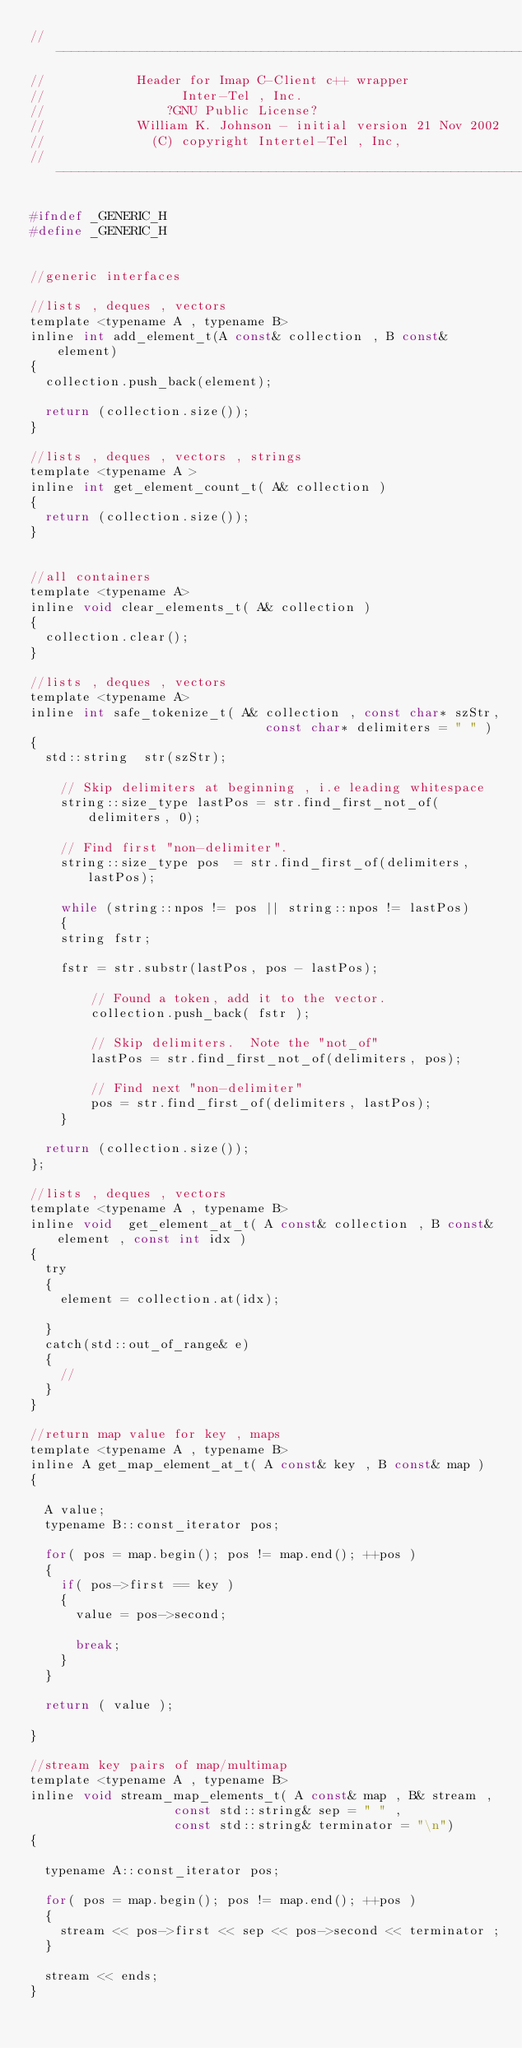Convert code to text. <code><loc_0><loc_0><loc_500><loc_500><_C_>//--------------------------------------------------------------------------------
//						Header for Imap C-Client c++ wrapper			  
//								  Inter-Tel , Inc.								  
//								?GNU Public License?							  
//						William K. Johnson - initial version 21 Nov 2002
//							(C) copyright Intertel-Tel , Inc,
//--------------------------------------------------------------------------------

#ifndef _GENERIC_H
#define _GENERIC_H


//generic interfaces

//lists , deques , vectors 
template <typename A , typename B>
inline int add_element_t(A const& collection , B const& element)
{
	collection.push_back(element);	
		
	return (collection.size());		
}

//lists , deques , vectors , strings
template <typename A >
inline int get_element_count_t( A& collection ) 
{
	return (collection.size());
}


//all containers
template <typename A>
inline void clear_elements_t( A& collection ) 
{
	collection.clear();
}

//lists , deques , vectors
template <typename A>
inline int safe_tokenize_t( A& collection , const char* szStr,
						                   const char* delimiters = " " )
{
	std::string  str(szStr);

    // Skip delimiters at beginning , i.e leading whitespace
    string::size_type lastPos = str.find_first_not_of(delimiters, 0);

    // Find first "non-delimiter".
    string::size_type pos  = str.find_first_of(delimiters, lastPos);

    while (string::npos != pos || string::npos != lastPos)
    {
		string fstr;

		fstr = str.substr(lastPos, pos - lastPos);

        // Found a token, add it to the vector.
        collection.push_back( fstr );

        // Skip delimiters.  Note the "not_of"
        lastPos = str.find_first_not_of(delimiters, pos);

        // Find next "non-delimiter"
        pos = str.find_first_of(delimiters, lastPos);
    }

	return (collection.size()); 
};

//lists , deques , vectors
template <typename A , typename B>
inline void  get_element_at_t( A const& collection , B const& element , const int idx )
{
	try
	{
		element = collection.at(idx);	

	}
	catch(std::out_of_range& e)
	{
		//
	}	
}

//return map value for key , maps
template <typename A , typename B>
inline A get_map_element_at_t( A const& key , B const& map )
{

	A value;
	typename B::const_iterator pos;

	for( pos = map.begin(); pos != map.end(); ++pos )
	{
		if( pos->first == key )
		{
			value = pos->second;

			break;
		}
	}

	return ( value );

}

//stream key pairs of map/multimap
template <typename A , typename B>
inline void stream_map_elements_t( A const& map , B& stream , 
								   const std::string& sep = " " ,
								   const std::string& terminator = "\n")
{
	
	typename A::const_iterator pos;

	for( pos = map.begin(); pos != map.end(); ++pos )
	{
		stream << pos->first << sep << pos->second << terminator ;
	}

	stream << ends;
}
</code> 